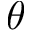<formula> <loc_0><loc_0><loc_500><loc_500>\theta</formula> 